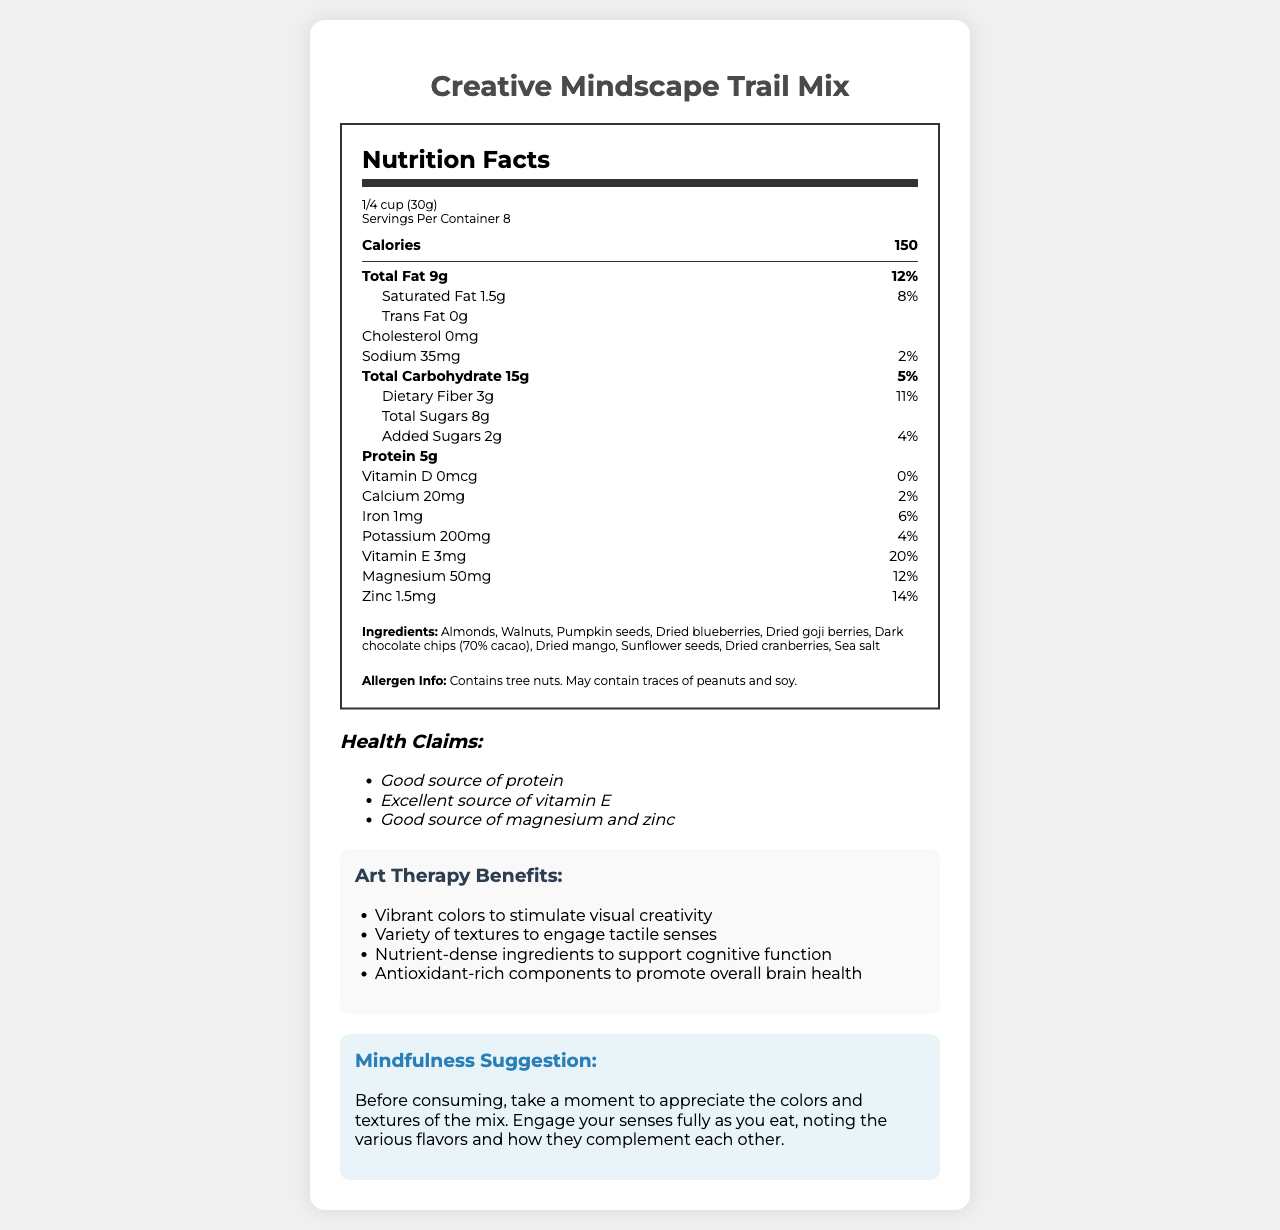what is the serving size? The serving size is listed under the serving information in the Nutrition Facts section.
Answer: 1/4 cup (30g) how many calories are in a single serving? The number of calories per serving is prominently displayed at the top of the Nutrition Facts section.
Answer: 150 what percentage of the daily value of saturated fat does one serving contain? The daily value percentage for saturated fat is given next to its amount in the Nutrition Facts section.
Answer: 8% what is the amount of dietary fiber per serving? The amount of dietary fiber per serving is listed in the Total Carbohydrate section of the Nutrition Facts.
Answer: 3g List three ingredients included in the trail mix. The ingredients are listed at the bottom of the Nutrition Facts label.
Answer: Almonds, Walnuts, Pumpkin seeds how much calcium is in one serving? The amount of calcium per serving is listed along with its daily value percentage in the Nutrition Facts section.
Answer: 20mg Is this trail mix a good source of protein? A. Yes B. No Under the health claims section, the document states that it is a "Good source of protein."
Answer: A. Yes Which nutrient is highest in daily value percentage in a single serving? A. Vitamin D B. Vitamin E C. Iron D. Magnesium Vitamin E has a daily value percentage of 20%, which is the highest among the listed nutrients.
Answer: B. Vitamin E Does the trail mix contain any trans fat? The amount of trans fat is listed as "0g" in the Nutrition Facts section.
Answer: No Summarize the key benefits of the trail mix related to art therapy. The document features a section on art therapy benefits, detailing how the product's visual and tactile elements, alongside its nutrient content, support creative and cognitive functions. Additionally, a mindfulness suggestion encourages fully engaging the senses when eating.
Answer: The trail mix uses vibrant colors to stimulate creativity, offers a variety of textures to engage tactile senses, includes nutrient-dense ingredients to support cognitive function, and contains antioxidant-rich components to promote overall brain health. A mindfulness suggestion advises appreciating the colors and textures before consuming. What is the daily value percentage of potassium in the trail mix? The daily value percentage for potassium is listed alongside its amount in the Nutrition Facts section.
Answer: 4% Is there any information given about the source of the ingredients in the trail mix? The document does not provide any information regarding the source of the ingredients.
Answer: Cannot be determined Does the trail mix contain peanuts? The allergen information section states that the product contains tree nuts and may contain traces of peanuts and soy.
Answer: May contain traces Is there any vitamin D in the trail mix? The amount of vitamin D is listed as "0mcg" in the Nutrition Facts section, indicating there is no vitamin D in the trail mix.
Answer: No List two ingredients in the trail mix that are dried fruits. The dried fruit ingredients are listed in the Ingredients section of the document.
Answer: Dried blueberries, Dried goji berries 